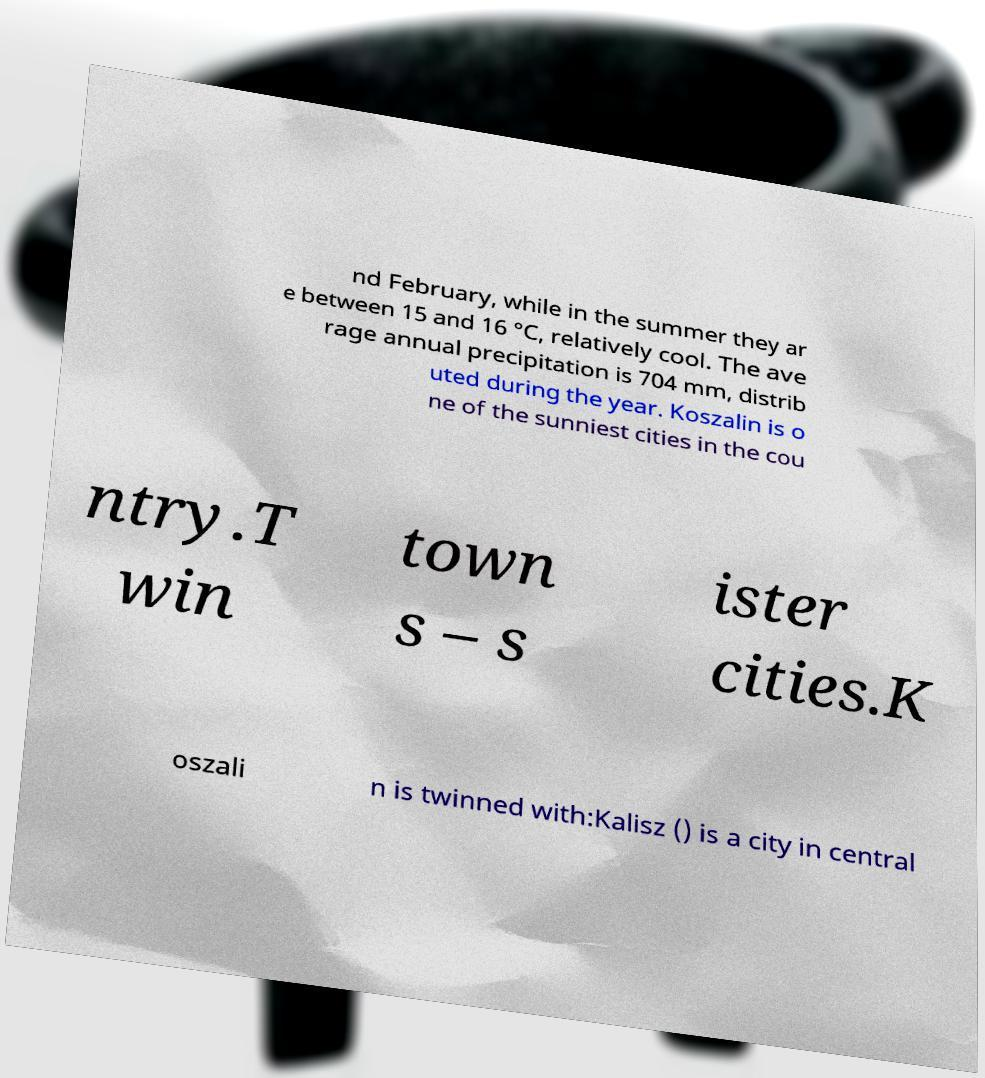I need the written content from this picture converted into text. Can you do that? nd February, while in the summer they ar e between 15 and 16 °C, relatively cool. The ave rage annual precipitation is 704 mm, distrib uted during the year. Koszalin is o ne of the sunniest cities in the cou ntry.T win town s – s ister cities.K oszali n is twinned with:Kalisz () is a city in central 